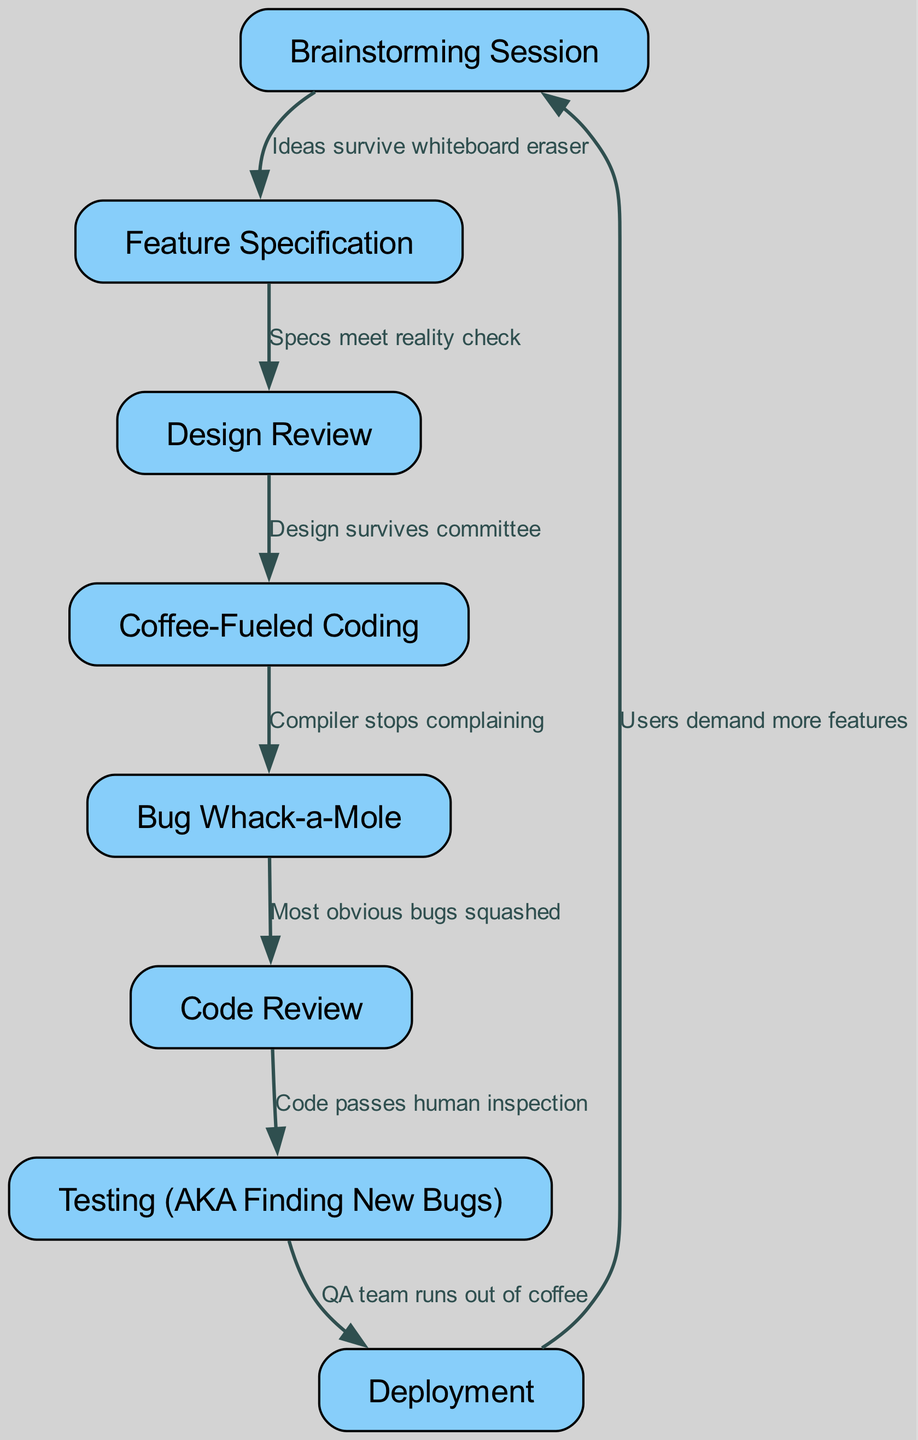What's the first step in the process? The diagram shows a flow starting from the node labeled "Brainstorming Session," which is the initial step. Therefore, it establishes the starting point of the feature implementation process.
Answer: Brainstorming Session How many nodes are in the diagram? By counting the nodes listed in the provided data, there are a total of eight distinct nodes in the flowchart.
Answer: 8 What node follows "Code Review"? The flow connects "Code Review" to "Testing (AKA Finding New Bugs)" as the subsequent step, indicating the process that follows the review of the code.
Answer: Testing (AKA Finding New Bugs) What relationship does "Design Review" have with "Feature Specification"? The diagram shows an edge between "Feature Specification" and "Design Review," with the label indicating that specifications are checked against reality, establishing a conditional connection between these two steps.
Answer: Specs meet reality check What happens if the "QA team runs out of coffee"? The edge from "Testing" to "Deployment" suggests that when the QA team runs out of coffee, it leads to deployment, indicating perhaps a rush to push the feature live despite potential issues.
Answer: Deployment What is the final step in the feature implementation process? The flowchart culminates with "Deployment," which signifies the end of the feature implementation journey, showcasing where the newly developed feature actually goes live.
Answer: Deployment Which step is known as "Bug Whack-a-Mole"? The step in the diagram that refers to this amusing term is directly labeled "Bug Whack-a-Mole," indicating the phase where programmers address bugs one by one like hitting moles in a carnival game.
Answer: Bug Whack-a-Mole What is the implication of users demanding more features? The last edge from "Deployment" back to "Brainstorming Session" illustrates that once features are deployed, the cycle repeats with users requesting additional enhancements, perpetuating the development cycle.
Answer: Users demand more features 